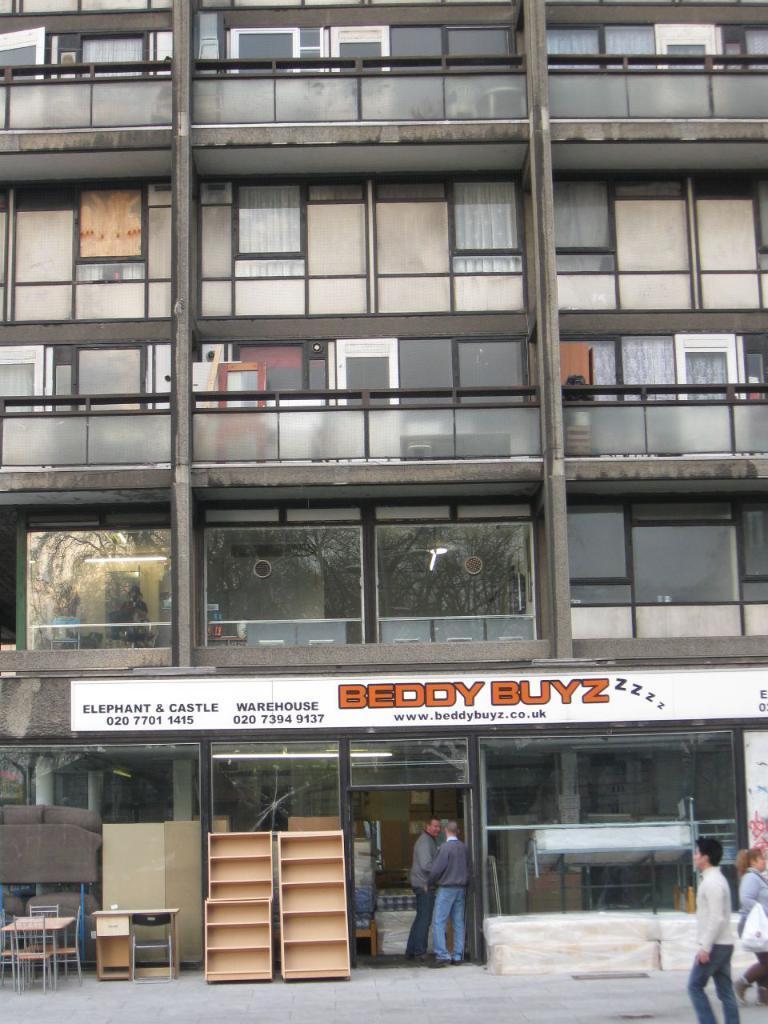Please provide a concise description of this image. This is an outside view. On the right side, I can see a man and a woman are walking on the road. In the background there is a building. In front of this building I can see two tables, chairs, a couch, few racks are placed on the floor and also two people are standing. I can see a white color board which is attached to the wall. On this board I can see some text. 